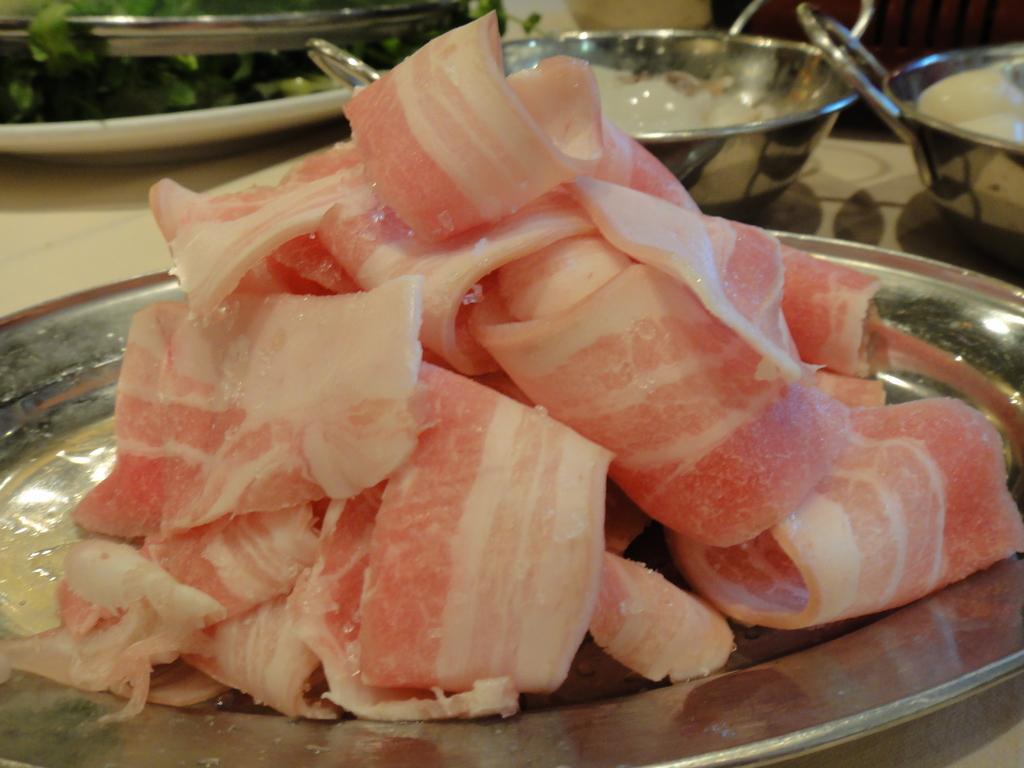Please provide a concise description of this image. In this image there is one table, on the table there are some plates. In the foreground there is one plate, on the plate there is some food item and in the background there are some bowls. 